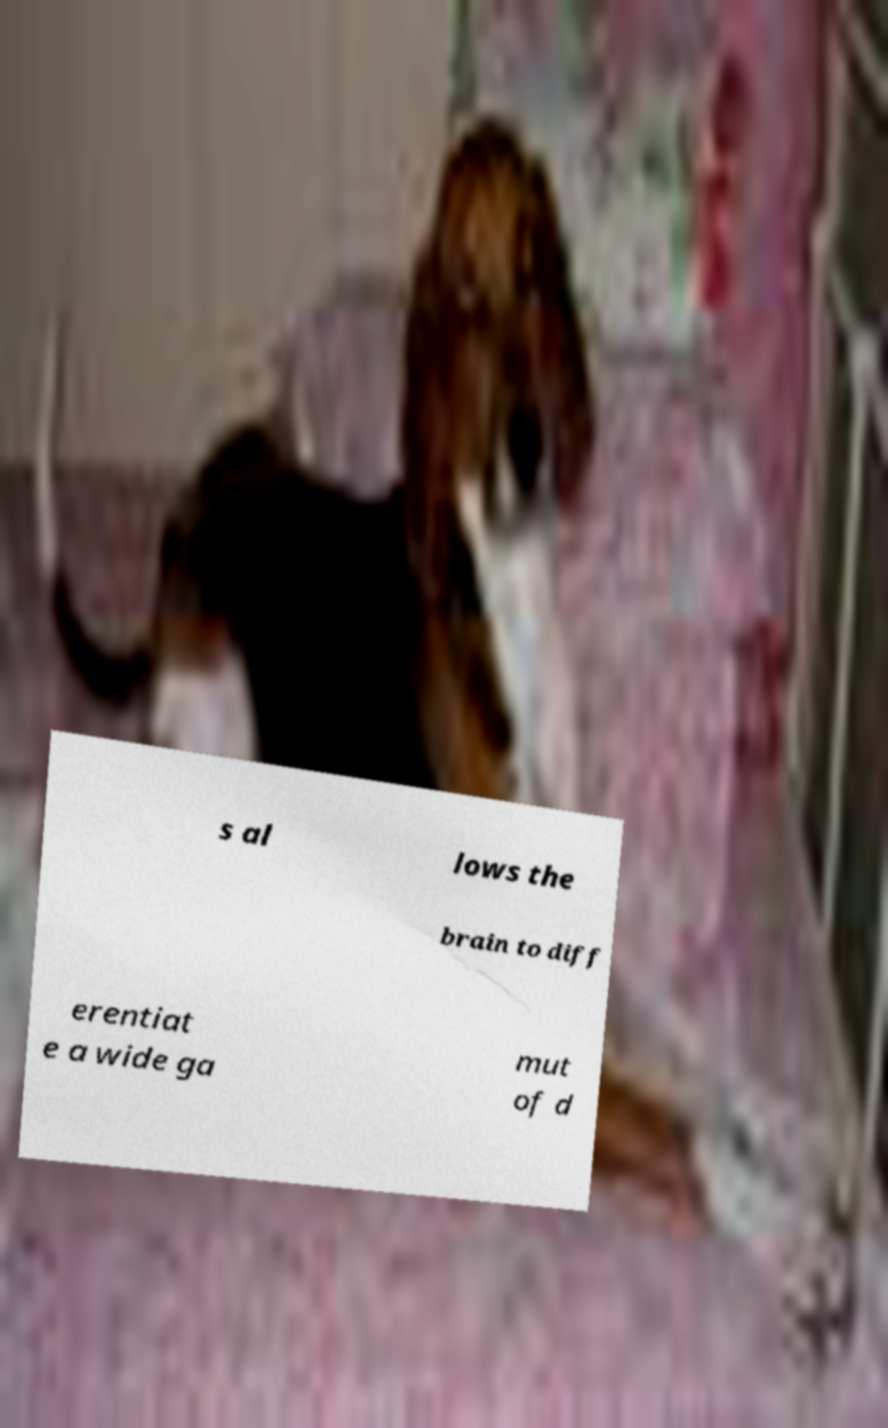Can you read and provide the text displayed in the image?This photo seems to have some interesting text. Can you extract and type it out for me? s al lows the brain to diff erentiat e a wide ga mut of d 